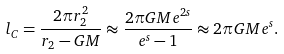<formula> <loc_0><loc_0><loc_500><loc_500>l _ { C } = \frac { 2 \pi r _ { 2 } ^ { 2 } } { r _ { 2 } - G M } \approx \frac { 2 \pi G M e ^ { 2 s } } { e ^ { s } - 1 } \approx 2 \pi G M e ^ { s } .</formula> 